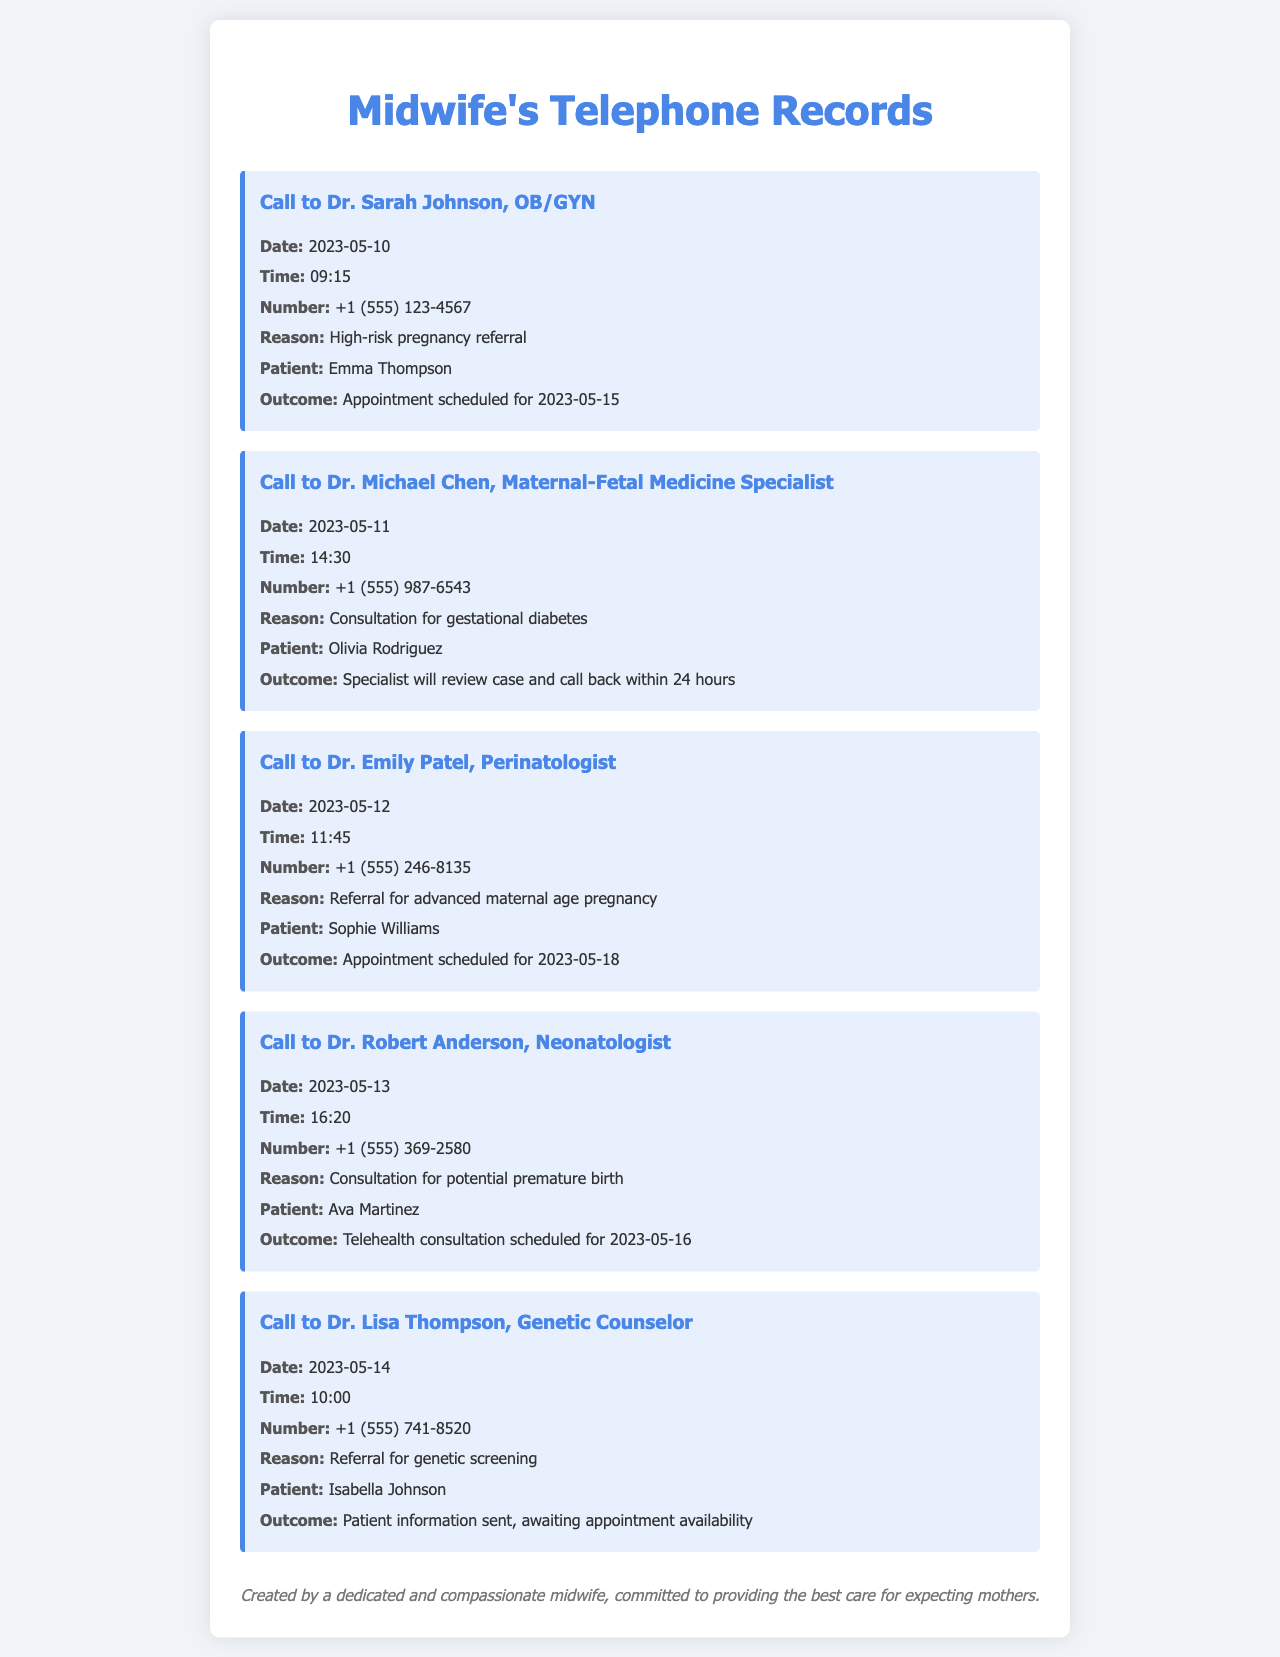what is the date of the call to Dr. Sarah Johnson? The date is listed in the record of the call to Dr. Sarah Johnson.
Answer: 2023-05-10 what was the outcome of the call to Dr. Michael Chen? The outcome is mentioned in the record of the call to Dr. Michael Chen, which indicates the next steps.
Answer: Specialist will review case and call back within 24 hours who was referred to Dr. Emily Patel? The patient's name is provided in the record of the call to Dr. Emily Patel.
Answer: Sophie Williams what was the reason for the call to Dr. Robert Anderson? The reason is specified in the record of the call to Dr. Robert Anderson.
Answer: Consultation for potential premature birth how many patients had appointments scheduled following their calls? This requires counting the records where an appointment was scheduled, which are particularly noted in their outcomes.
Answer: 3 who was referred for genetic screening? The patient's name is found in the record of the call to Dr. Lisa Thompson.
Answer: Isabella Johnson what time was the call to Dr. Lisa Thompson? The time of the call is recorded in the call to Dr. Lisa Thompson.
Answer: 10:00 how many different specialists were contacted? This question involves identifying the number of unique specialists mentioned across all records.
Answer: 5 what type of specialist is Dr. Michael Chen? The specialty of Dr. Michael Chen is noted in the document specifically about the call made to him.
Answer: Maternal-Fetal Medicine Specialist 